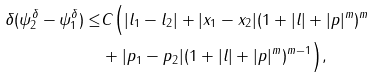Convert formula to latex. <formula><loc_0><loc_0><loc_500><loc_500>\delta ( \psi _ { 2 } ^ { \delta } - \psi _ { 1 } ^ { \delta } ) \leq & C \Big { ( } | l _ { 1 } - l _ { 2 } | + | x _ { 1 } - x _ { 2 } | ( 1 + | l | + | p | ^ { m } ) ^ { m } \\ & + | p _ { 1 } - p _ { 2 } | ( 1 + | l | + | p | ^ { m } ) ^ { m - 1 } \Big { ) } ,</formula> 